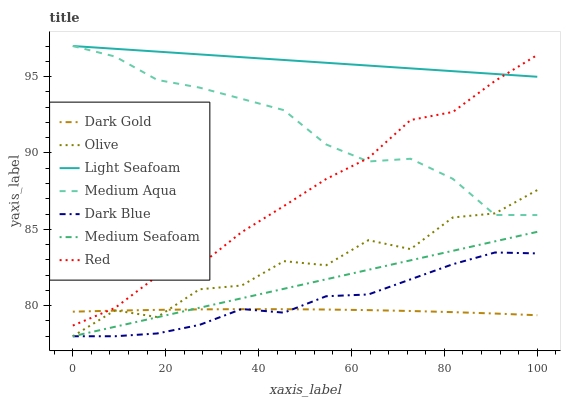Does Dark Gold have the minimum area under the curve?
Answer yes or no. Yes. Does Light Seafoam have the maximum area under the curve?
Answer yes or no. Yes. Does Dark Blue have the minimum area under the curve?
Answer yes or no. No. Does Dark Blue have the maximum area under the curve?
Answer yes or no. No. Is Medium Seafoam the smoothest?
Answer yes or no. Yes. Is Olive the roughest?
Answer yes or no. Yes. Is Dark Blue the smoothest?
Answer yes or no. No. Is Dark Blue the roughest?
Answer yes or no. No. Does Medium Aqua have the lowest value?
Answer yes or no. No. Does Light Seafoam have the highest value?
Answer yes or no. Yes. Does Dark Blue have the highest value?
Answer yes or no. No. Is Olive less than Red?
Answer yes or no. Yes. Is Light Seafoam greater than Dark Gold?
Answer yes or no. Yes. Does Light Seafoam intersect Red?
Answer yes or no. Yes. Is Light Seafoam less than Red?
Answer yes or no. No. Is Light Seafoam greater than Red?
Answer yes or no. No. Does Olive intersect Red?
Answer yes or no. No. 